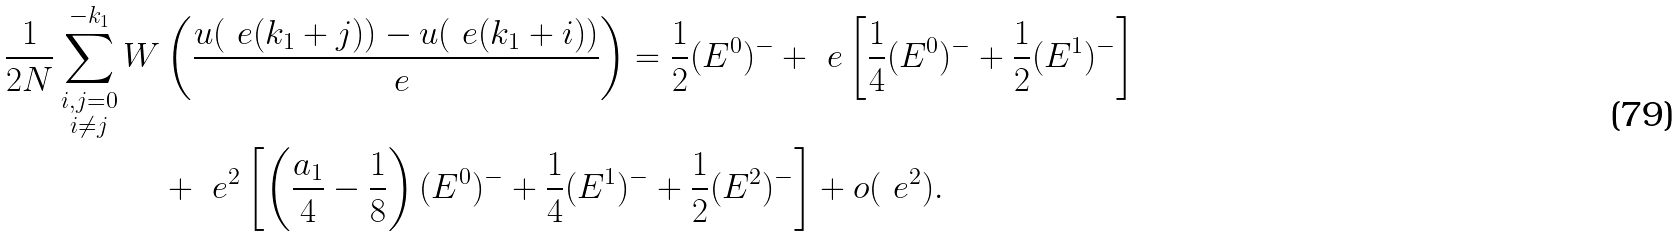Convert formula to latex. <formula><loc_0><loc_0><loc_500><loc_500>\frac { 1 } { 2 N } \sum _ { \substack { i , j = 0 \\ i \neq j } } ^ { - k _ { 1 } } W & \left ( \frac { u ( \ e ( k _ { 1 } + j ) ) - u ( \ e ( k _ { 1 } + i ) ) } { \ e } \right ) = \frac { 1 } { 2 } ( E ^ { 0 } ) ^ { - } + \ e \left [ \frac { 1 } { 4 } ( E ^ { 0 } ) ^ { - } + \frac { 1 } { 2 } ( E ^ { 1 } ) ^ { - } \right ] \\ & + \ e ^ { 2 } \left [ \left ( \frac { a _ { 1 } } { 4 } - \frac { 1 } { 8 } \right ) ( E ^ { 0 } ) ^ { - } + \frac { 1 } { 4 } ( E ^ { 1 } ) ^ { - } + \frac { 1 } { 2 } ( E ^ { 2 } ) ^ { - } \right ] + o ( \ e ^ { 2 } ) .</formula> 